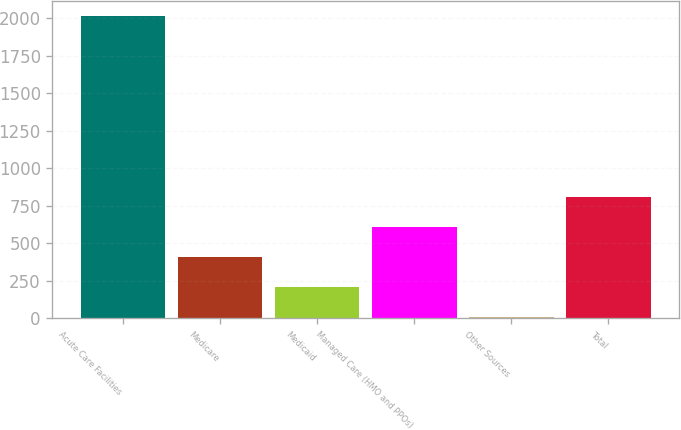Convert chart. <chart><loc_0><loc_0><loc_500><loc_500><bar_chart><fcel>Acute Care Facilities<fcel>Medicare<fcel>Medicaid<fcel>Managed Care (HMO and PPOs)<fcel>Other Sources<fcel>Total<nl><fcel>2014<fcel>408.4<fcel>207.7<fcel>609.1<fcel>7<fcel>809.8<nl></chart> 